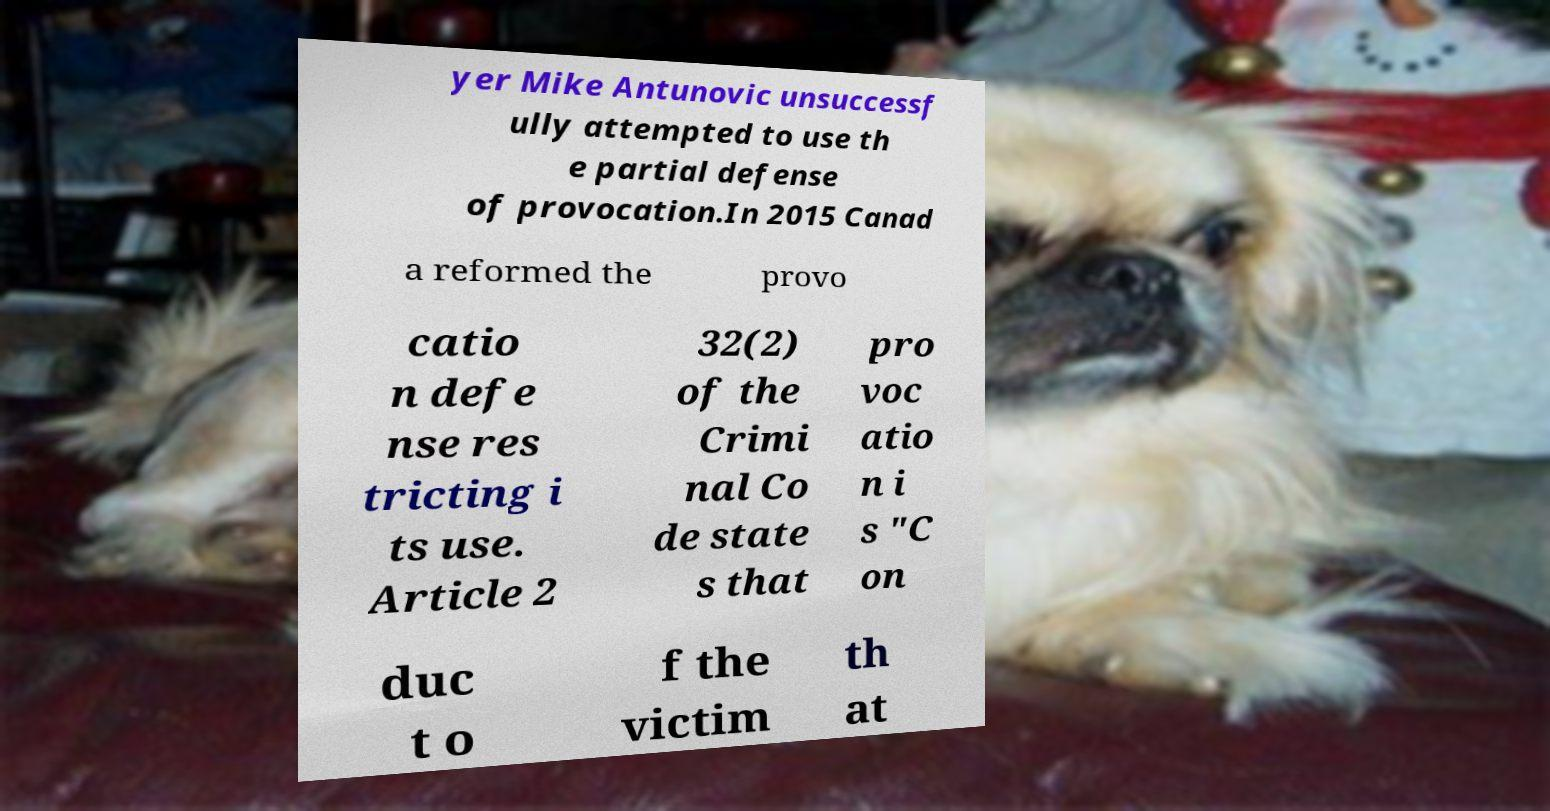I need the written content from this picture converted into text. Can you do that? yer Mike Antunovic unsuccessf ully attempted to use th e partial defense of provocation.In 2015 Canad a reformed the provo catio n defe nse res tricting i ts use. Article 2 32(2) of the Crimi nal Co de state s that pro voc atio n i s "C on duc t o f the victim th at 